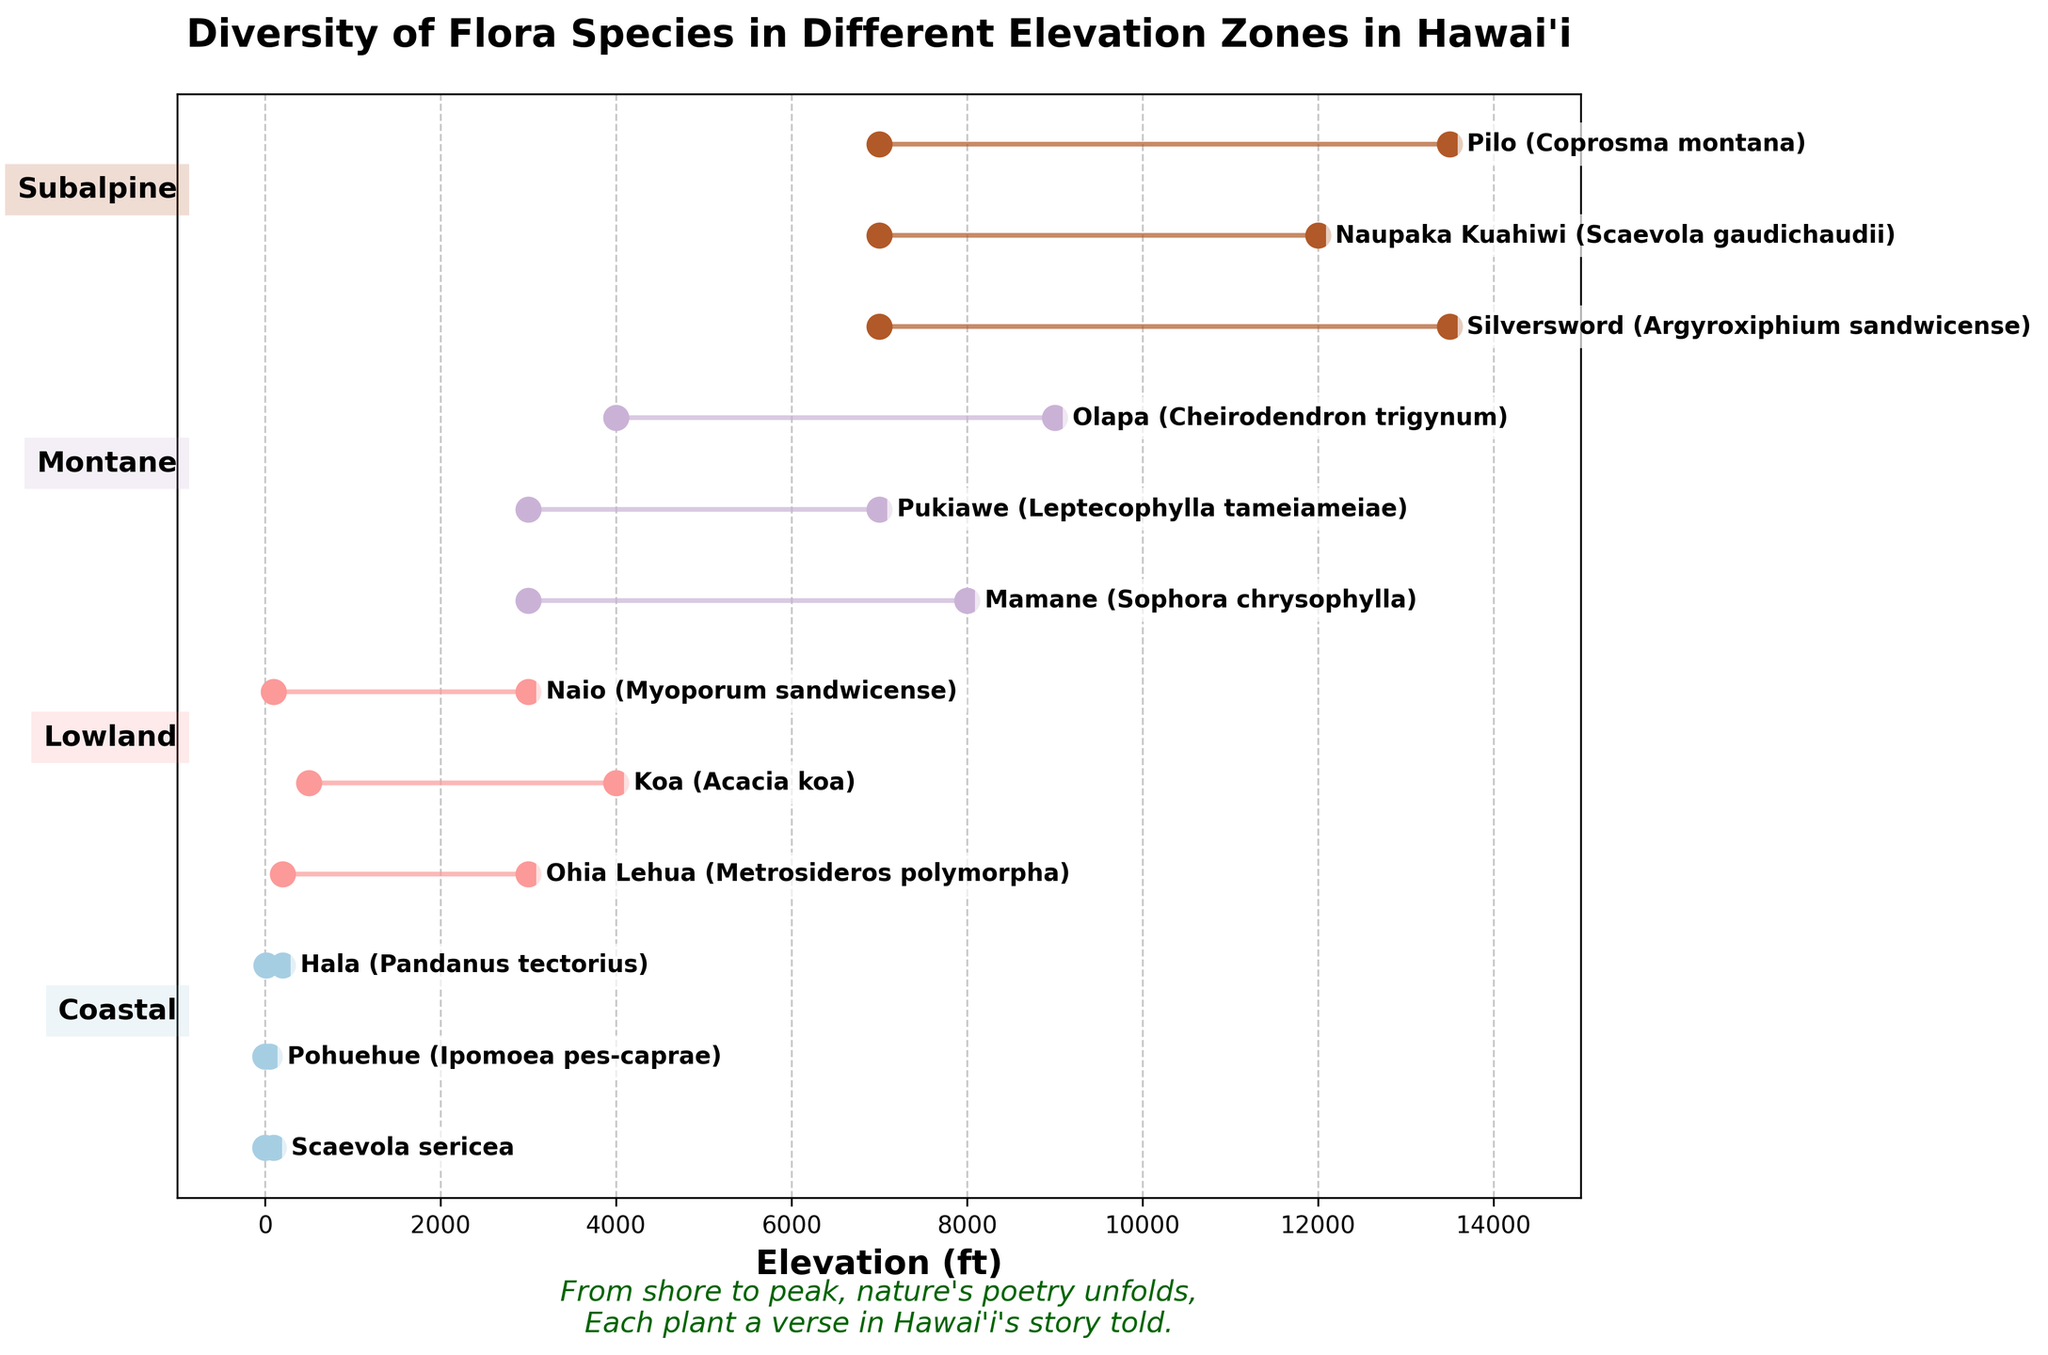What is the title of the figure? The title is usually displayed at the top of the figure. It serves to summarize the main content or theme of the plot.
Answer: "Diversity of Flora Species in Different Elevation Zones in Hawai'i" How many species are represented in the Montane zone? Look for sections of the plot labeled "Montane" and count the number of species listed within this zone.
Answer: 3 Which species has the highest maximum elevation and what is this elevation? Identify the species with the highest maximum value on the x-axis and read off the corresponding data point.
Answer: Silversword (13500 ft) What is the range of elevations for Koa? Find the data points for the species Koa and subtract the minimum elevation from the maximum elevation.
Answer: 3500 ft Which elevation zone contains the species Pohuehue? Look for Pohuehue on the plot and find the corresponding elevation zone labeled on the y-axis.
Answer: Coastal In which elevation zone do all species have a minimum elevation above 7000 ft? Identify the zones where all species have their minimum points starting above 7000 ft.
Answer: Subalpine Compare the elevation ranges of Ohia Lehua and Naio. Which has a wider range? Calculate the elevation range for both species by subtracting their minimum elevation from their maximum and compare the two results.
Answer: Ohia Lehua (range: 2800 ft) is wider than Naio (range: 2900 ft) Which species spans the entire Subalpine zone based on elevation? Look at all species in the Subalpine zone and find the ones that start at 7000 ft and go up to at least 12000 ft.
Answer: Silversword and Pilo If you were to list the Coastal species from lowest to highest maximum elevation, what would the order be? Examine the maximum elevations of all Coastal species and order them accordingly.
Answer: Pohuehue (50 ft), Scaevola sericea (100 ft), Hala (200 ft) What's the elevation difference between the highest point of Hala and the lowest point of Ohia Lehua? Find the highest elevation for Hala and subtract the lowest elevation for Ohia Lehua from it.
Answer: 200 ft (Hala max) - 200 ft (Ohia Lehua min) = 0 ft 